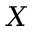<formula> <loc_0><loc_0><loc_500><loc_500>X</formula> 